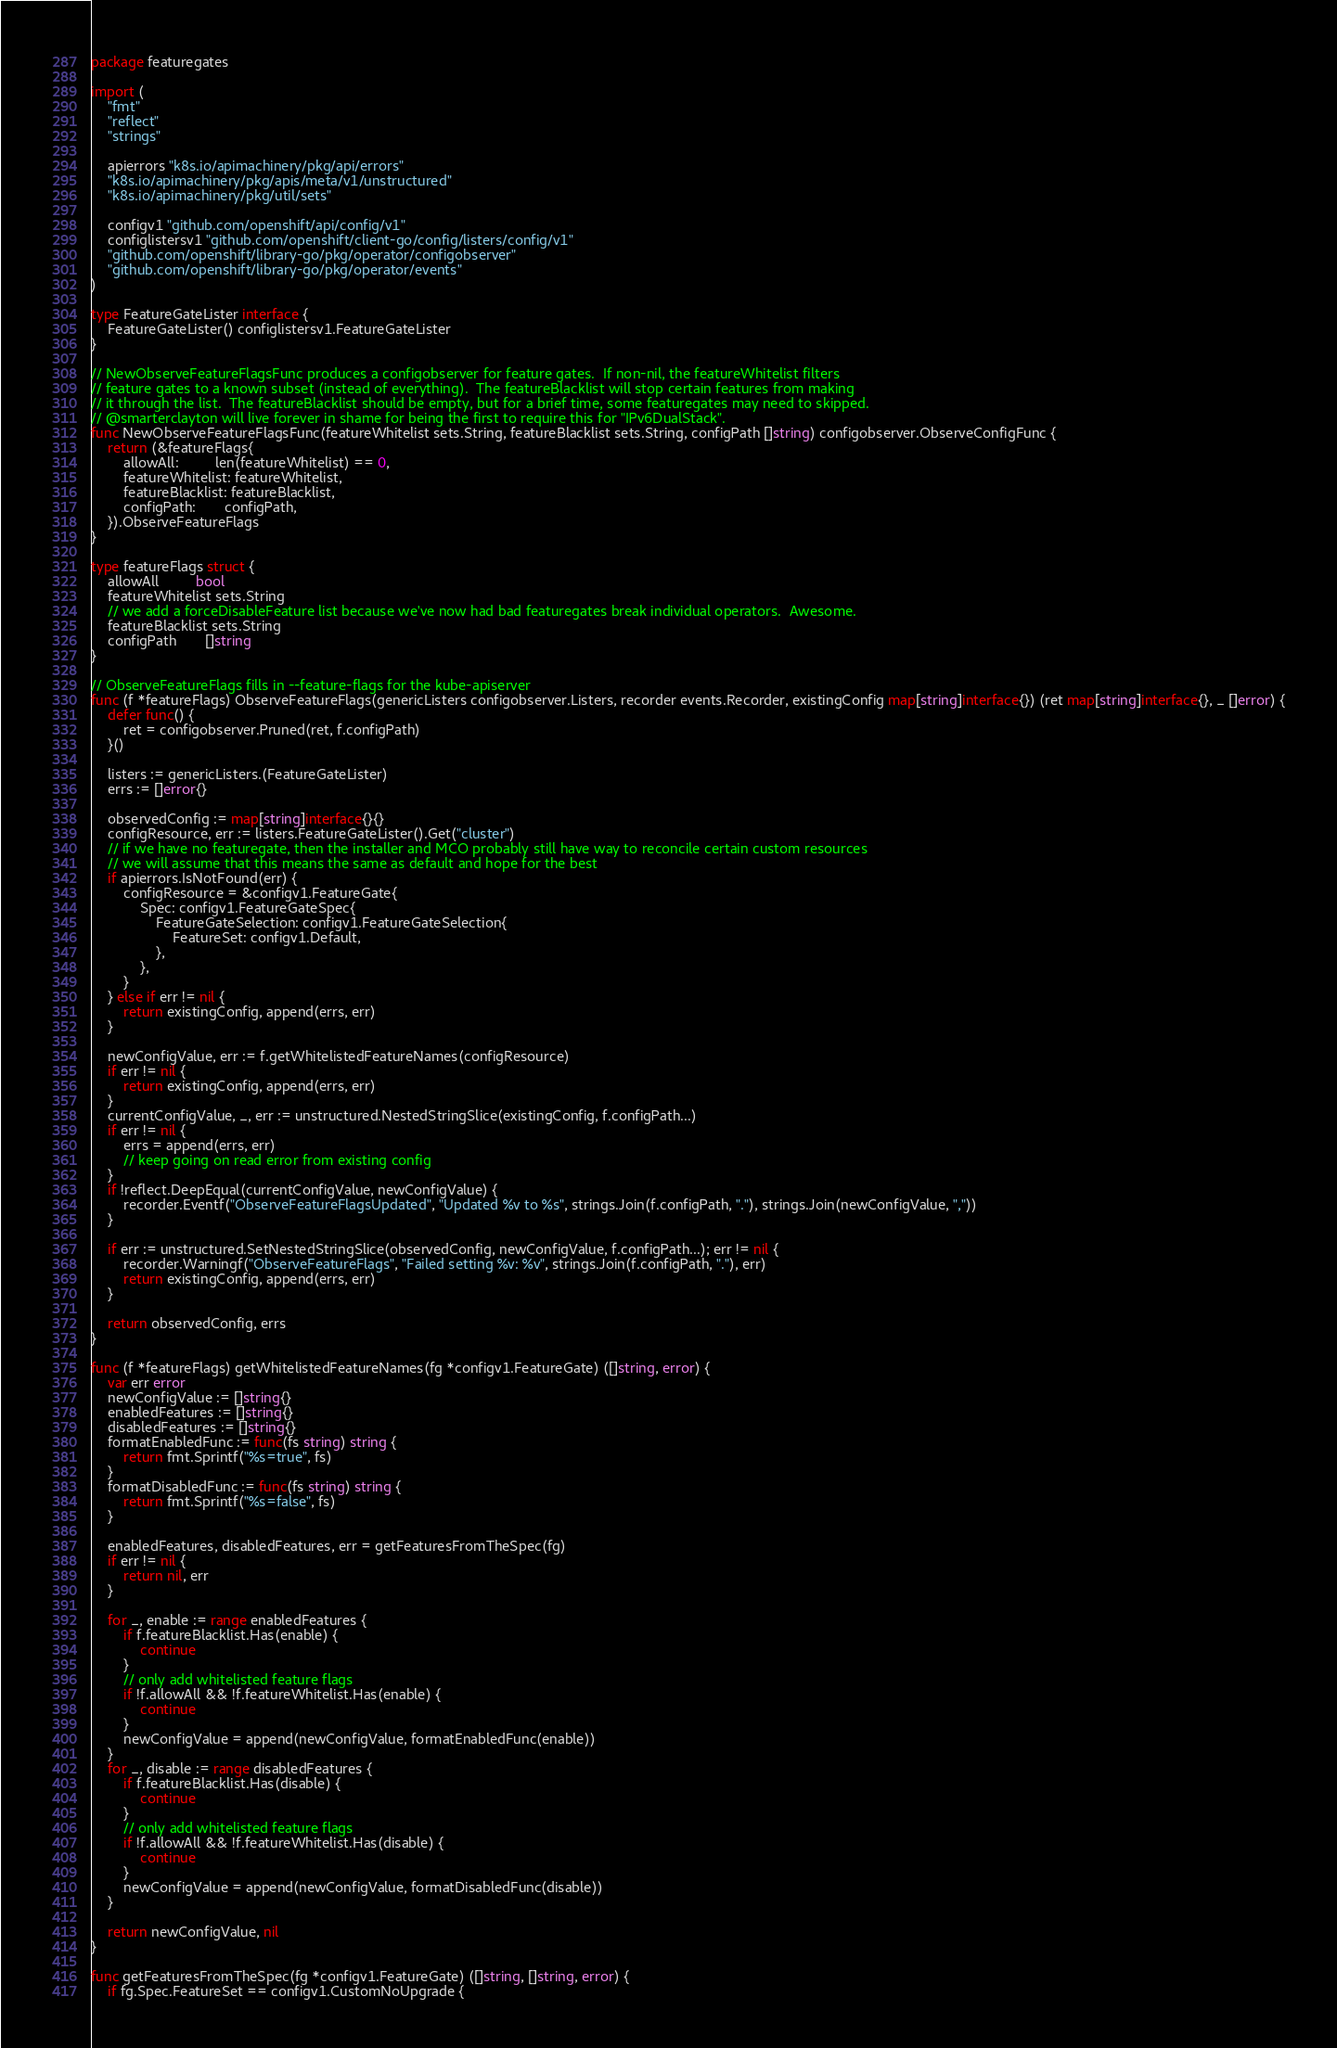<code> <loc_0><loc_0><loc_500><loc_500><_Go_>package featuregates

import (
	"fmt"
	"reflect"
	"strings"

	apierrors "k8s.io/apimachinery/pkg/api/errors"
	"k8s.io/apimachinery/pkg/apis/meta/v1/unstructured"
	"k8s.io/apimachinery/pkg/util/sets"

	configv1 "github.com/openshift/api/config/v1"
	configlistersv1 "github.com/openshift/client-go/config/listers/config/v1"
	"github.com/openshift/library-go/pkg/operator/configobserver"
	"github.com/openshift/library-go/pkg/operator/events"
)

type FeatureGateLister interface {
	FeatureGateLister() configlistersv1.FeatureGateLister
}

// NewObserveFeatureFlagsFunc produces a configobserver for feature gates.  If non-nil, the featureWhitelist filters
// feature gates to a known subset (instead of everything).  The featureBlacklist will stop certain features from making
// it through the list.  The featureBlacklist should be empty, but for a brief time, some featuregates may need to skipped.
// @smarterclayton will live forever in shame for being the first to require this for "IPv6DualStack".
func NewObserveFeatureFlagsFunc(featureWhitelist sets.String, featureBlacklist sets.String, configPath []string) configobserver.ObserveConfigFunc {
	return (&featureFlags{
		allowAll:         len(featureWhitelist) == 0,
		featureWhitelist: featureWhitelist,
		featureBlacklist: featureBlacklist,
		configPath:       configPath,
	}).ObserveFeatureFlags
}

type featureFlags struct {
	allowAll         bool
	featureWhitelist sets.String
	// we add a forceDisableFeature list because we've now had bad featuregates break individual operators.  Awesome.
	featureBlacklist sets.String
	configPath       []string
}

// ObserveFeatureFlags fills in --feature-flags for the kube-apiserver
func (f *featureFlags) ObserveFeatureFlags(genericListers configobserver.Listers, recorder events.Recorder, existingConfig map[string]interface{}) (ret map[string]interface{}, _ []error) {
	defer func() {
		ret = configobserver.Pruned(ret, f.configPath)
	}()

	listers := genericListers.(FeatureGateLister)
	errs := []error{}

	observedConfig := map[string]interface{}{}
	configResource, err := listers.FeatureGateLister().Get("cluster")
	// if we have no featuregate, then the installer and MCO probably still have way to reconcile certain custom resources
	// we will assume that this means the same as default and hope for the best
	if apierrors.IsNotFound(err) {
		configResource = &configv1.FeatureGate{
			Spec: configv1.FeatureGateSpec{
				FeatureGateSelection: configv1.FeatureGateSelection{
					FeatureSet: configv1.Default,
				},
			},
		}
	} else if err != nil {
		return existingConfig, append(errs, err)
	}

	newConfigValue, err := f.getWhitelistedFeatureNames(configResource)
	if err != nil {
		return existingConfig, append(errs, err)
	}
	currentConfigValue, _, err := unstructured.NestedStringSlice(existingConfig, f.configPath...)
	if err != nil {
		errs = append(errs, err)
		// keep going on read error from existing config
	}
	if !reflect.DeepEqual(currentConfigValue, newConfigValue) {
		recorder.Eventf("ObserveFeatureFlagsUpdated", "Updated %v to %s", strings.Join(f.configPath, "."), strings.Join(newConfigValue, ","))
	}

	if err := unstructured.SetNestedStringSlice(observedConfig, newConfigValue, f.configPath...); err != nil {
		recorder.Warningf("ObserveFeatureFlags", "Failed setting %v: %v", strings.Join(f.configPath, "."), err)
		return existingConfig, append(errs, err)
	}

	return observedConfig, errs
}

func (f *featureFlags) getWhitelistedFeatureNames(fg *configv1.FeatureGate) ([]string, error) {
	var err error
	newConfigValue := []string{}
	enabledFeatures := []string{}
	disabledFeatures := []string{}
	formatEnabledFunc := func(fs string) string {
		return fmt.Sprintf("%s=true", fs)
	}
	formatDisabledFunc := func(fs string) string {
		return fmt.Sprintf("%s=false", fs)
	}

	enabledFeatures, disabledFeatures, err = getFeaturesFromTheSpec(fg)
	if err != nil {
		return nil, err
	}

	for _, enable := range enabledFeatures {
		if f.featureBlacklist.Has(enable) {
			continue
		}
		// only add whitelisted feature flags
		if !f.allowAll && !f.featureWhitelist.Has(enable) {
			continue
		}
		newConfigValue = append(newConfigValue, formatEnabledFunc(enable))
	}
	for _, disable := range disabledFeatures {
		if f.featureBlacklist.Has(disable) {
			continue
		}
		// only add whitelisted feature flags
		if !f.allowAll && !f.featureWhitelist.Has(disable) {
			continue
		}
		newConfigValue = append(newConfigValue, formatDisabledFunc(disable))
	}

	return newConfigValue, nil
}

func getFeaturesFromTheSpec(fg *configv1.FeatureGate) ([]string, []string, error) {
	if fg.Spec.FeatureSet == configv1.CustomNoUpgrade {</code> 